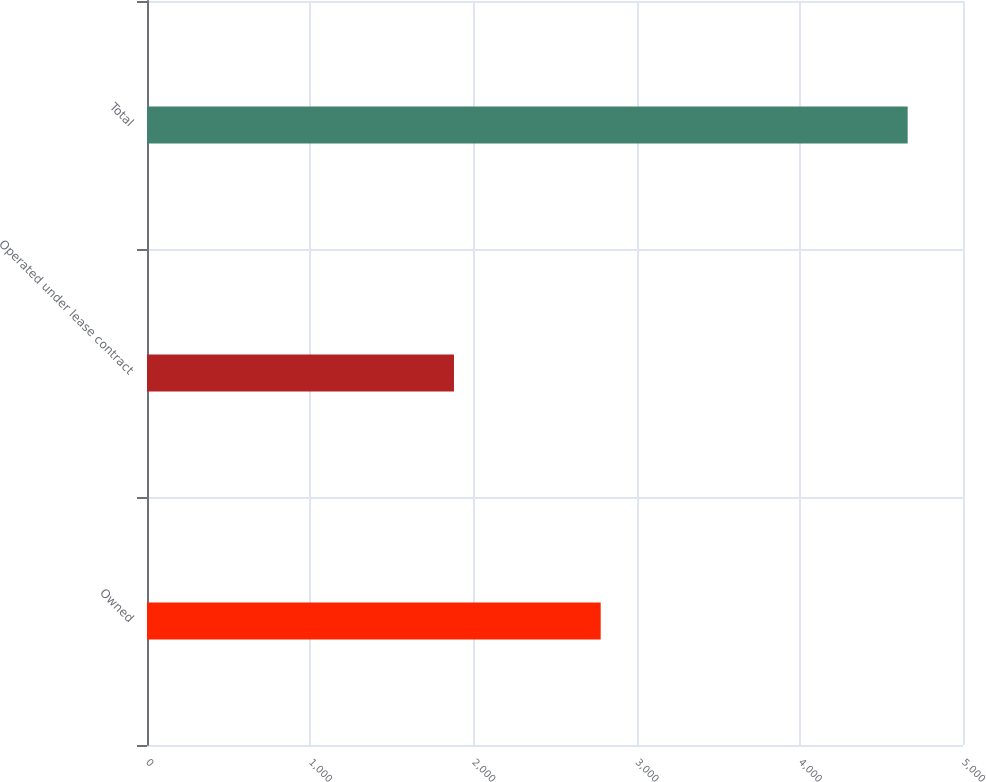Convert chart. <chart><loc_0><loc_0><loc_500><loc_500><bar_chart><fcel>Owned<fcel>Operated under lease contract<fcel>Total<nl><fcel>2780<fcel>1881<fcel>4661<nl></chart> 